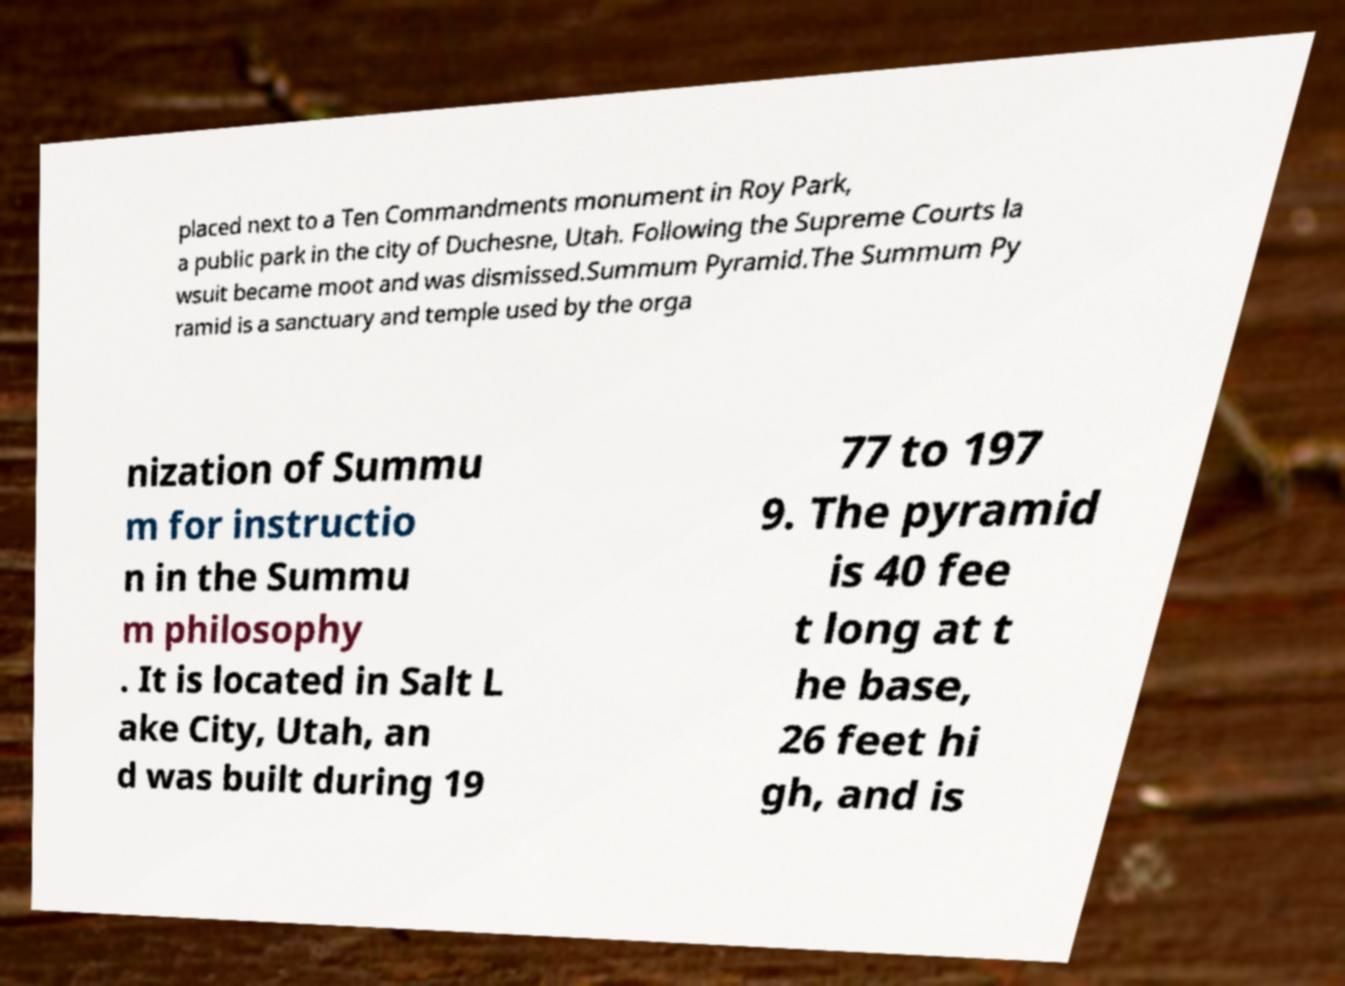Can you accurately transcribe the text from the provided image for me? placed next to a Ten Commandments monument in Roy Park, a public park in the city of Duchesne, Utah. Following the Supreme Courts la wsuit became moot and was dismissed.Summum Pyramid.The Summum Py ramid is a sanctuary and temple used by the orga nization of Summu m for instructio n in the Summu m philosophy . It is located in Salt L ake City, Utah, an d was built during 19 77 to 197 9. The pyramid is 40 fee t long at t he base, 26 feet hi gh, and is 